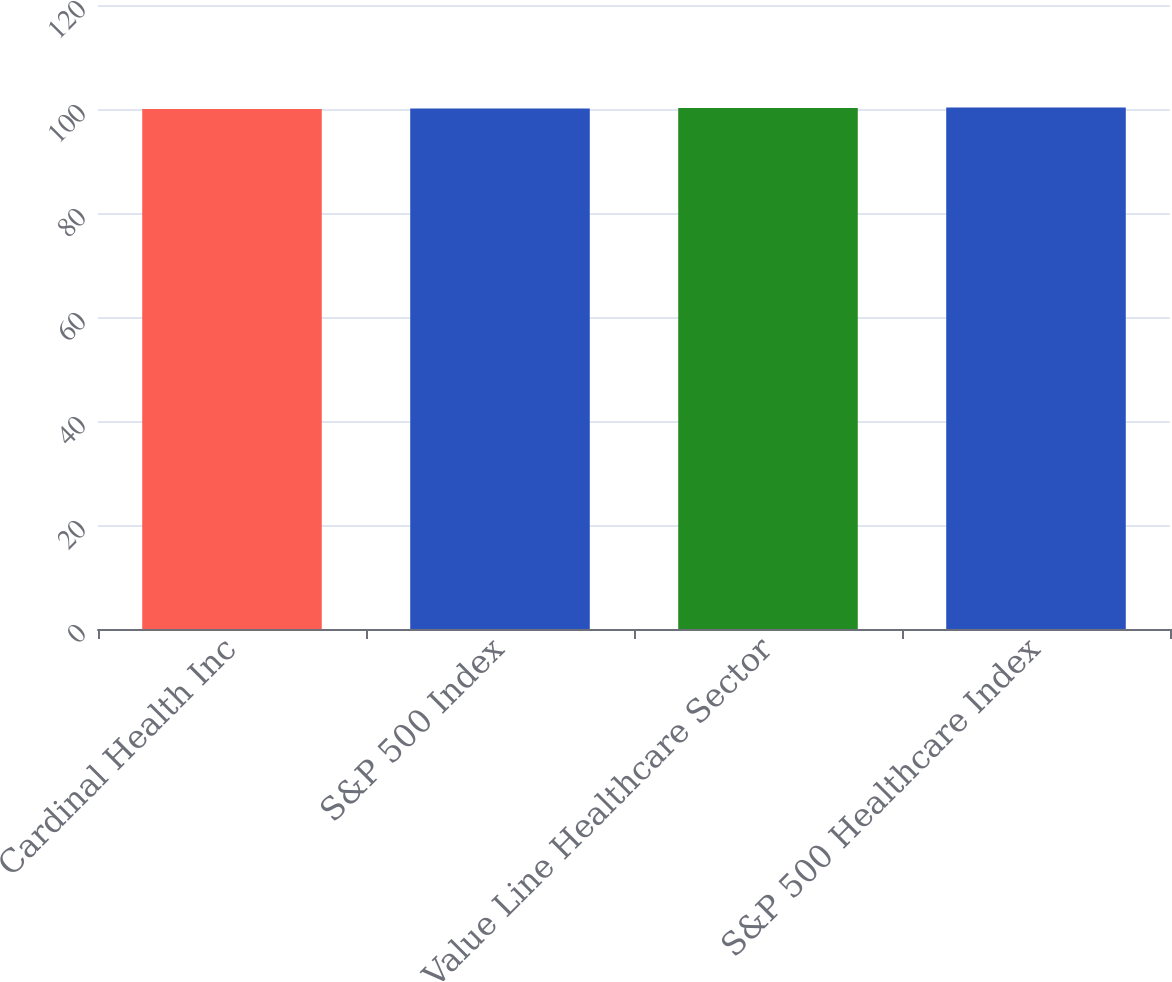Convert chart to OTSL. <chart><loc_0><loc_0><loc_500><loc_500><bar_chart><fcel>Cardinal Health Inc<fcel>S&P 500 Index<fcel>Value Line Healthcare Sector<fcel>S&P 500 Healthcare Index<nl><fcel>100<fcel>100.1<fcel>100.2<fcel>100.3<nl></chart> 